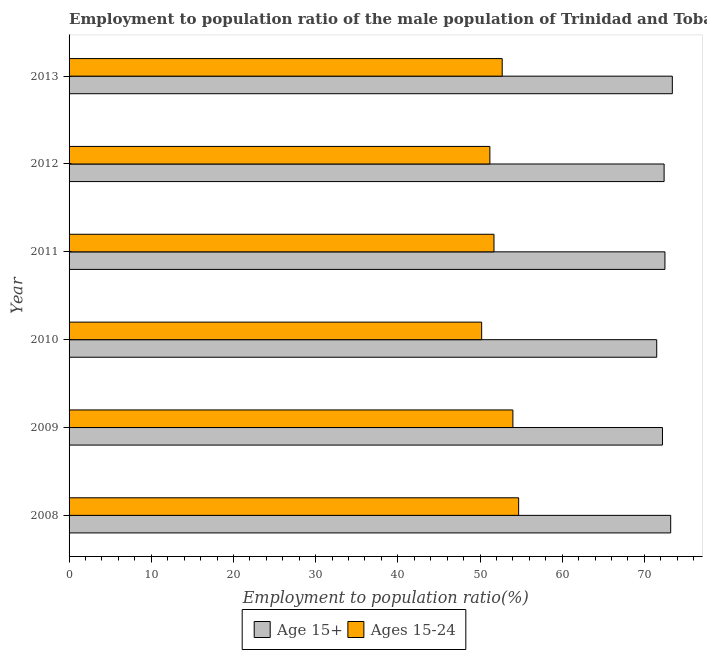How many different coloured bars are there?
Offer a terse response. 2. How many groups of bars are there?
Provide a succinct answer. 6. Are the number of bars per tick equal to the number of legend labels?
Make the answer very short. Yes. What is the label of the 6th group of bars from the top?
Ensure brevity in your answer.  2008. What is the employment to population ratio(age 15+) in 2012?
Make the answer very short. 72.4. Across all years, what is the maximum employment to population ratio(age 15+)?
Offer a very short reply. 73.4. Across all years, what is the minimum employment to population ratio(age 15-24)?
Make the answer very short. 50.2. In which year was the employment to population ratio(age 15+) maximum?
Offer a very short reply. 2013. In which year was the employment to population ratio(age 15-24) minimum?
Ensure brevity in your answer.  2010. What is the total employment to population ratio(age 15-24) in the graph?
Your answer should be compact. 314.5. What is the difference between the employment to population ratio(age 15+) in 2009 and the employment to population ratio(age 15-24) in 2012?
Provide a short and direct response. 21. What is the average employment to population ratio(age 15-24) per year?
Ensure brevity in your answer.  52.42. In the year 2011, what is the difference between the employment to population ratio(age 15+) and employment to population ratio(age 15-24)?
Your answer should be very brief. 20.8. In how many years, is the employment to population ratio(age 15-24) greater than 72 %?
Make the answer very short. 0. Is the employment to population ratio(age 15-24) in 2010 less than that in 2012?
Ensure brevity in your answer.  Yes. Is the sum of the employment to population ratio(age 15+) in 2009 and 2012 greater than the maximum employment to population ratio(age 15-24) across all years?
Ensure brevity in your answer.  Yes. What does the 2nd bar from the top in 2013 represents?
Ensure brevity in your answer.  Age 15+. What does the 2nd bar from the bottom in 2013 represents?
Provide a short and direct response. Ages 15-24. How many bars are there?
Give a very brief answer. 12. What is the difference between two consecutive major ticks on the X-axis?
Give a very brief answer. 10. How many legend labels are there?
Keep it short and to the point. 2. How are the legend labels stacked?
Provide a succinct answer. Horizontal. What is the title of the graph?
Give a very brief answer. Employment to population ratio of the male population of Trinidad and Tobago for different age-groups. What is the Employment to population ratio(%) of Age 15+ in 2008?
Make the answer very short. 73.2. What is the Employment to population ratio(%) of Ages 15-24 in 2008?
Your answer should be compact. 54.7. What is the Employment to population ratio(%) of Age 15+ in 2009?
Make the answer very short. 72.2. What is the Employment to population ratio(%) of Ages 15-24 in 2009?
Offer a terse response. 54. What is the Employment to population ratio(%) in Age 15+ in 2010?
Offer a very short reply. 71.5. What is the Employment to population ratio(%) of Ages 15-24 in 2010?
Give a very brief answer. 50.2. What is the Employment to population ratio(%) of Age 15+ in 2011?
Provide a short and direct response. 72.5. What is the Employment to population ratio(%) of Ages 15-24 in 2011?
Offer a very short reply. 51.7. What is the Employment to population ratio(%) in Age 15+ in 2012?
Provide a short and direct response. 72.4. What is the Employment to population ratio(%) in Ages 15-24 in 2012?
Give a very brief answer. 51.2. What is the Employment to population ratio(%) in Age 15+ in 2013?
Your response must be concise. 73.4. What is the Employment to population ratio(%) in Ages 15-24 in 2013?
Make the answer very short. 52.7. Across all years, what is the maximum Employment to population ratio(%) in Age 15+?
Make the answer very short. 73.4. Across all years, what is the maximum Employment to population ratio(%) of Ages 15-24?
Provide a short and direct response. 54.7. Across all years, what is the minimum Employment to population ratio(%) of Age 15+?
Your answer should be very brief. 71.5. Across all years, what is the minimum Employment to population ratio(%) in Ages 15-24?
Your response must be concise. 50.2. What is the total Employment to population ratio(%) in Age 15+ in the graph?
Keep it short and to the point. 435.2. What is the total Employment to population ratio(%) of Ages 15-24 in the graph?
Make the answer very short. 314.5. What is the difference between the Employment to population ratio(%) in Ages 15-24 in 2008 and that in 2009?
Keep it short and to the point. 0.7. What is the difference between the Employment to population ratio(%) of Age 15+ in 2008 and that in 2010?
Offer a terse response. 1.7. What is the difference between the Employment to population ratio(%) in Ages 15-24 in 2008 and that in 2010?
Give a very brief answer. 4.5. What is the difference between the Employment to population ratio(%) in Ages 15-24 in 2008 and that in 2013?
Provide a succinct answer. 2. What is the difference between the Employment to population ratio(%) in Ages 15-24 in 2009 and that in 2010?
Your answer should be very brief. 3.8. What is the difference between the Employment to population ratio(%) of Age 15+ in 2009 and that in 2013?
Your answer should be very brief. -1.2. What is the difference between the Employment to population ratio(%) in Ages 15-24 in 2010 and that in 2011?
Provide a short and direct response. -1.5. What is the difference between the Employment to population ratio(%) in Age 15+ in 2010 and that in 2012?
Offer a very short reply. -0.9. What is the difference between the Employment to population ratio(%) in Age 15+ in 2010 and that in 2013?
Offer a very short reply. -1.9. What is the difference between the Employment to population ratio(%) in Ages 15-24 in 2010 and that in 2013?
Provide a short and direct response. -2.5. What is the difference between the Employment to population ratio(%) of Ages 15-24 in 2011 and that in 2012?
Provide a succinct answer. 0.5. What is the difference between the Employment to population ratio(%) of Age 15+ in 2011 and that in 2013?
Give a very brief answer. -0.9. What is the difference between the Employment to population ratio(%) of Ages 15-24 in 2011 and that in 2013?
Offer a terse response. -1. What is the difference between the Employment to population ratio(%) in Age 15+ in 2012 and that in 2013?
Ensure brevity in your answer.  -1. What is the difference between the Employment to population ratio(%) in Age 15+ in 2008 and the Employment to population ratio(%) in Ages 15-24 in 2011?
Offer a terse response. 21.5. What is the difference between the Employment to population ratio(%) of Age 15+ in 2008 and the Employment to population ratio(%) of Ages 15-24 in 2012?
Make the answer very short. 22. What is the difference between the Employment to population ratio(%) of Age 15+ in 2009 and the Employment to population ratio(%) of Ages 15-24 in 2013?
Ensure brevity in your answer.  19.5. What is the difference between the Employment to population ratio(%) in Age 15+ in 2010 and the Employment to population ratio(%) in Ages 15-24 in 2011?
Offer a terse response. 19.8. What is the difference between the Employment to population ratio(%) in Age 15+ in 2010 and the Employment to population ratio(%) in Ages 15-24 in 2012?
Your answer should be compact. 20.3. What is the difference between the Employment to population ratio(%) in Age 15+ in 2011 and the Employment to population ratio(%) in Ages 15-24 in 2012?
Ensure brevity in your answer.  21.3. What is the difference between the Employment to population ratio(%) of Age 15+ in 2011 and the Employment to population ratio(%) of Ages 15-24 in 2013?
Ensure brevity in your answer.  19.8. What is the average Employment to population ratio(%) of Age 15+ per year?
Give a very brief answer. 72.53. What is the average Employment to population ratio(%) in Ages 15-24 per year?
Your response must be concise. 52.42. In the year 2010, what is the difference between the Employment to population ratio(%) of Age 15+ and Employment to population ratio(%) of Ages 15-24?
Your response must be concise. 21.3. In the year 2011, what is the difference between the Employment to population ratio(%) in Age 15+ and Employment to population ratio(%) in Ages 15-24?
Your response must be concise. 20.8. In the year 2012, what is the difference between the Employment to population ratio(%) of Age 15+ and Employment to population ratio(%) of Ages 15-24?
Offer a very short reply. 21.2. In the year 2013, what is the difference between the Employment to population ratio(%) in Age 15+ and Employment to population ratio(%) in Ages 15-24?
Make the answer very short. 20.7. What is the ratio of the Employment to population ratio(%) in Age 15+ in 2008 to that in 2009?
Provide a succinct answer. 1.01. What is the ratio of the Employment to population ratio(%) in Ages 15-24 in 2008 to that in 2009?
Make the answer very short. 1.01. What is the ratio of the Employment to population ratio(%) of Age 15+ in 2008 to that in 2010?
Your answer should be very brief. 1.02. What is the ratio of the Employment to population ratio(%) in Ages 15-24 in 2008 to that in 2010?
Ensure brevity in your answer.  1.09. What is the ratio of the Employment to population ratio(%) in Age 15+ in 2008 to that in 2011?
Your answer should be very brief. 1.01. What is the ratio of the Employment to population ratio(%) in Ages 15-24 in 2008 to that in 2011?
Make the answer very short. 1.06. What is the ratio of the Employment to population ratio(%) in Age 15+ in 2008 to that in 2012?
Your response must be concise. 1.01. What is the ratio of the Employment to population ratio(%) in Ages 15-24 in 2008 to that in 2012?
Make the answer very short. 1.07. What is the ratio of the Employment to population ratio(%) in Age 15+ in 2008 to that in 2013?
Your answer should be compact. 1. What is the ratio of the Employment to population ratio(%) in Ages 15-24 in 2008 to that in 2013?
Your response must be concise. 1.04. What is the ratio of the Employment to population ratio(%) of Age 15+ in 2009 to that in 2010?
Keep it short and to the point. 1.01. What is the ratio of the Employment to population ratio(%) of Ages 15-24 in 2009 to that in 2010?
Your answer should be compact. 1.08. What is the ratio of the Employment to population ratio(%) in Age 15+ in 2009 to that in 2011?
Your response must be concise. 1. What is the ratio of the Employment to population ratio(%) in Ages 15-24 in 2009 to that in 2011?
Make the answer very short. 1.04. What is the ratio of the Employment to population ratio(%) in Ages 15-24 in 2009 to that in 2012?
Keep it short and to the point. 1.05. What is the ratio of the Employment to population ratio(%) of Age 15+ in 2009 to that in 2013?
Provide a succinct answer. 0.98. What is the ratio of the Employment to population ratio(%) of Ages 15-24 in 2009 to that in 2013?
Give a very brief answer. 1.02. What is the ratio of the Employment to population ratio(%) of Age 15+ in 2010 to that in 2011?
Offer a very short reply. 0.99. What is the ratio of the Employment to population ratio(%) in Age 15+ in 2010 to that in 2012?
Provide a short and direct response. 0.99. What is the ratio of the Employment to population ratio(%) in Ages 15-24 in 2010 to that in 2012?
Your answer should be compact. 0.98. What is the ratio of the Employment to population ratio(%) in Age 15+ in 2010 to that in 2013?
Offer a very short reply. 0.97. What is the ratio of the Employment to population ratio(%) in Ages 15-24 in 2010 to that in 2013?
Offer a very short reply. 0.95. What is the ratio of the Employment to population ratio(%) of Ages 15-24 in 2011 to that in 2012?
Your answer should be very brief. 1.01. What is the ratio of the Employment to population ratio(%) of Age 15+ in 2011 to that in 2013?
Offer a very short reply. 0.99. What is the ratio of the Employment to population ratio(%) in Ages 15-24 in 2011 to that in 2013?
Provide a short and direct response. 0.98. What is the ratio of the Employment to population ratio(%) of Age 15+ in 2012 to that in 2013?
Make the answer very short. 0.99. What is the ratio of the Employment to population ratio(%) in Ages 15-24 in 2012 to that in 2013?
Offer a terse response. 0.97. What is the difference between the highest and the second highest Employment to population ratio(%) in Age 15+?
Keep it short and to the point. 0.2. What is the difference between the highest and the lowest Employment to population ratio(%) of Age 15+?
Make the answer very short. 1.9. 